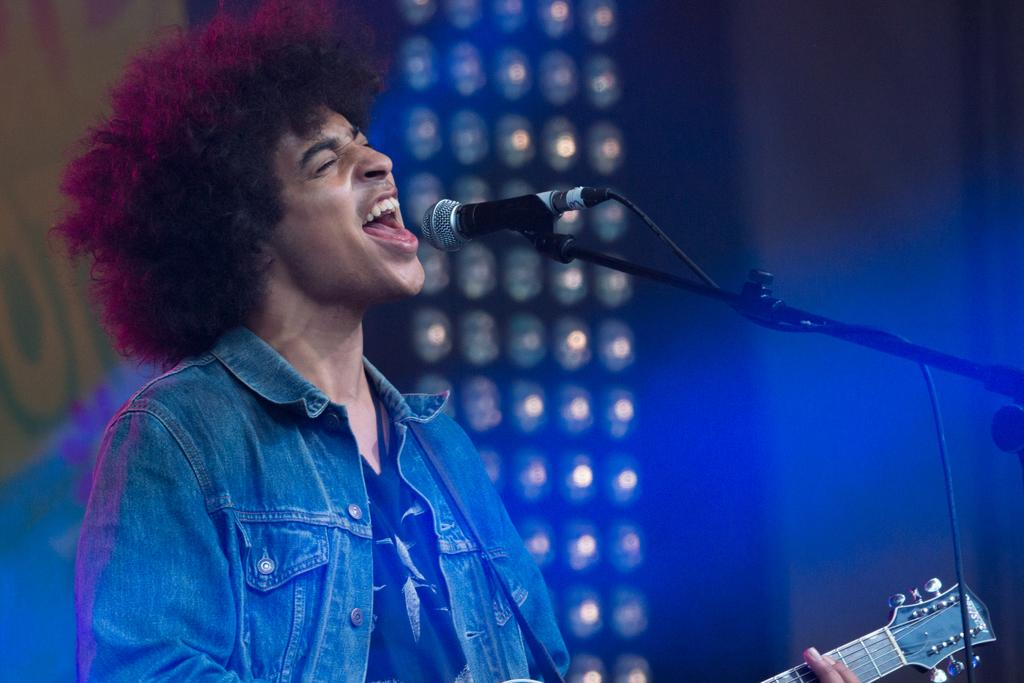What is the man doing in the image? The man is playing a guitar and singing. What is the man standing in front of? The man is in front of a microphone. What is the man wearing in the image? The man is wearing a jacket. What type of lighting is present in the image? There are focusing lights in the image. How is the microphone positioned in the image? There is a microphone with a holder in the image. What type of pickle is being used as a prop in the image? There is no pickle present in the image. Can you compare the structure of the microphone in the image to a similar microphone? There is no need to compare the structure of the microphone in the image to a similar microphone, as the image provides a clear depiction of the microphone and its holder. 